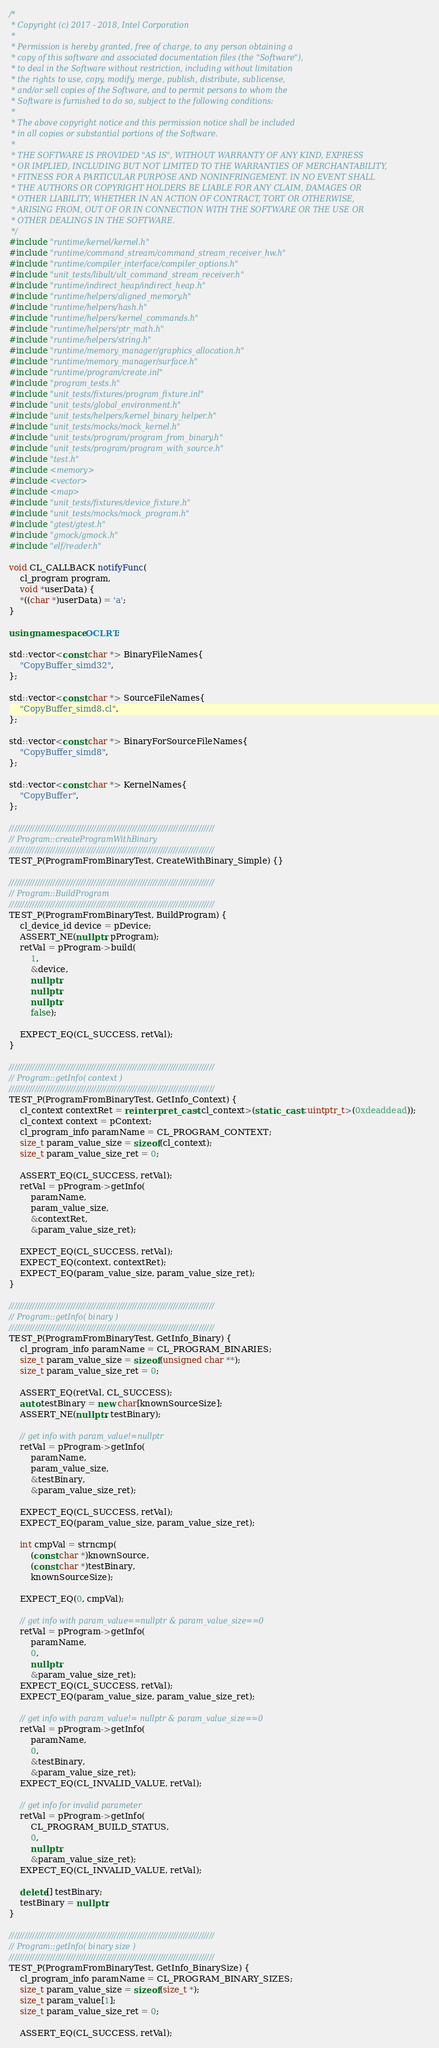Convert code to text. <code><loc_0><loc_0><loc_500><loc_500><_C++_>/*
 * Copyright (c) 2017 - 2018, Intel Corporation
 *
 * Permission is hereby granted, free of charge, to any person obtaining a
 * copy of this software and associated documentation files (the "Software"),
 * to deal in the Software without restriction, including without limitation
 * the rights to use, copy, modify, merge, publish, distribute, sublicense,
 * and/or sell copies of the Software, and to permit persons to whom the
 * Software is furnished to do so, subject to the following conditions:
 *
 * The above copyright notice and this permission notice shall be included
 * in all copies or substantial portions of the Software.
 *
 * THE SOFTWARE IS PROVIDED "AS IS", WITHOUT WARRANTY OF ANY KIND, EXPRESS
 * OR IMPLIED, INCLUDING BUT NOT LIMITED TO THE WARRANTIES OF MERCHANTABILITY,
 * FITNESS FOR A PARTICULAR PURPOSE AND NONINFRINGEMENT. IN NO EVENT SHALL
 * THE AUTHORS OR COPYRIGHT HOLDERS BE LIABLE FOR ANY CLAIM, DAMAGES OR
 * OTHER LIABILITY, WHETHER IN AN ACTION OF CONTRACT, TORT OR OTHERWISE,
 * ARISING FROM, OUT OF OR IN CONNECTION WITH THE SOFTWARE OR THE USE OR
 * OTHER DEALINGS IN THE SOFTWARE.
 */
#include "runtime/kernel/kernel.h"
#include "runtime/command_stream/command_stream_receiver_hw.h"
#include "runtime/compiler_interface/compiler_options.h"
#include "unit_tests/libult/ult_command_stream_receiver.h"
#include "runtime/indirect_heap/indirect_heap.h"
#include "runtime/helpers/aligned_memory.h"
#include "runtime/helpers/hash.h"
#include "runtime/helpers/kernel_commands.h"
#include "runtime/helpers/ptr_math.h"
#include "runtime/helpers/string.h"
#include "runtime/memory_manager/graphics_allocation.h"
#include "runtime/memory_manager/surface.h"
#include "runtime/program/create.inl"
#include "program_tests.h"
#include "unit_tests/fixtures/program_fixture.inl"
#include "unit_tests/global_environment.h"
#include "unit_tests/helpers/kernel_binary_helper.h"
#include "unit_tests/mocks/mock_kernel.h"
#include "unit_tests/program/program_from_binary.h"
#include "unit_tests/program/program_with_source.h"
#include "test.h"
#include <memory>
#include <vector>
#include <map>
#include "unit_tests/fixtures/device_fixture.h"
#include "unit_tests/mocks/mock_program.h"
#include "gtest/gtest.h"
#include "gmock/gmock.h"
#include "elf/reader.h"

void CL_CALLBACK notifyFunc(
    cl_program program,
    void *userData) {
    *((char *)userData) = 'a';
}

using namespace OCLRT;

std::vector<const char *> BinaryFileNames{
    "CopyBuffer_simd32",
};

std::vector<const char *> SourceFileNames{
    "CopyBuffer_simd8.cl",
};

std::vector<const char *> BinaryForSourceFileNames{
    "CopyBuffer_simd8",
};

std::vector<const char *> KernelNames{
    "CopyBuffer",
};

////////////////////////////////////////////////////////////////////////////////
// Program::createProgramWithBinary
////////////////////////////////////////////////////////////////////////////////
TEST_P(ProgramFromBinaryTest, CreateWithBinary_Simple) {}

////////////////////////////////////////////////////////////////////////////////
// Program::BuildProgram
////////////////////////////////////////////////////////////////////////////////
TEST_P(ProgramFromBinaryTest, BuildProgram) {
    cl_device_id device = pDevice;
    ASSERT_NE(nullptr, pProgram);
    retVal = pProgram->build(
        1,
        &device,
        nullptr,
        nullptr,
        nullptr,
        false);

    EXPECT_EQ(CL_SUCCESS, retVal);
}

////////////////////////////////////////////////////////////////////////////////
// Program::getInfo( context )
////////////////////////////////////////////////////////////////////////////////
TEST_P(ProgramFromBinaryTest, GetInfo_Context) {
    cl_context contextRet = reinterpret_cast<cl_context>(static_cast<uintptr_t>(0xdeaddead));
    cl_context context = pContext;
    cl_program_info paramName = CL_PROGRAM_CONTEXT;
    size_t param_value_size = sizeof(cl_context);
    size_t param_value_size_ret = 0;

    ASSERT_EQ(CL_SUCCESS, retVal);
    retVal = pProgram->getInfo(
        paramName,
        param_value_size,
        &contextRet,
        &param_value_size_ret);

    EXPECT_EQ(CL_SUCCESS, retVal);
    EXPECT_EQ(context, contextRet);
    EXPECT_EQ(param_value_size, param_value_size_ret);
}

////////////////////////////////////////////////////////////////////////////////
// Program::getInfo( binary )
////////////////////////////////////////////////////////////////////////////////
TEST_P(ProgramFromBinaryTest, GetInfo_Binary) {
    cl_program_info paramName = CL_PROGRAM_BINARIES;
    size_t param_value_size = sizeof(unsigned char **);
    size_t param_value_size_ret = 0;

    ASSERT_EQ(retVal, CL_SUCCESS);
    auto testBinary = new char[knownSourceSize];
    ASSERT_NE(nullptr, testBinary);

    // get info with param_value!=nullptr
    retVal = pProgram->getInfo(
        paramName,
        param_value_size,
        &testBinary,
        &param_value_size_ret);

    EXPECT_EQ(CL_SUCCESS, retVal);
    EXPECT_EQ(param_value_size, param_value_size_ret);

    int cmpVal = strncmp(
        (const char *)knownSource,
        (const char *)testBinary,
        knownSourceSize);

    EXPECT_EQ(0, cmpVal);

    // get info with param_value==nullptr & param_value_size==0
    retVal = pProgram->getInfo(
        paramName,
        0,
        nullptr,
        &param_value_size_ret);
    EXPECT_EQ(CL_SUCCESS, retVal);
    EXPECT_EQ(param_value_size, param_value_size_ret);

    // get info with param_value!= nullptr & param_value_size==0
    retVal = pProgram->getInfo(
        paramName,
        0,
        &testBinary,
        &param_value_size_ret);
    EXPECT_EQ(CL_INVALID_VALUE, retVal);

    // get info for invalid parameter
    retVal = pProgram->getInfo(
        CL_PROGRAM_BUILD_STATUS,
        0,
        nullptr,
        &param_value_size_ret);
    EXPECT_EQ(CL_INVALID_VALUE, retVal);

    delete[] testBinary;
    testBinary = nullptr;
}

////////////////////////////////////////////////////////////////////////////////
// Program::getInfo( binary size )
////////////////////////////////////////////////////////////////////////////////
TEST_P(ProgramFromBinaryTest, GetInfo_BinarySize) {
    cl_program_info paramName = CL_PROGRAM_BINARY_SIZES;
    size_t param_value_size = sizeof(size_t *);
    size_t param_value[1];
    size_t param_value_size_ret = 0;

    ASSERT_EQ(CL_SUCCESS, retVal);</code> 